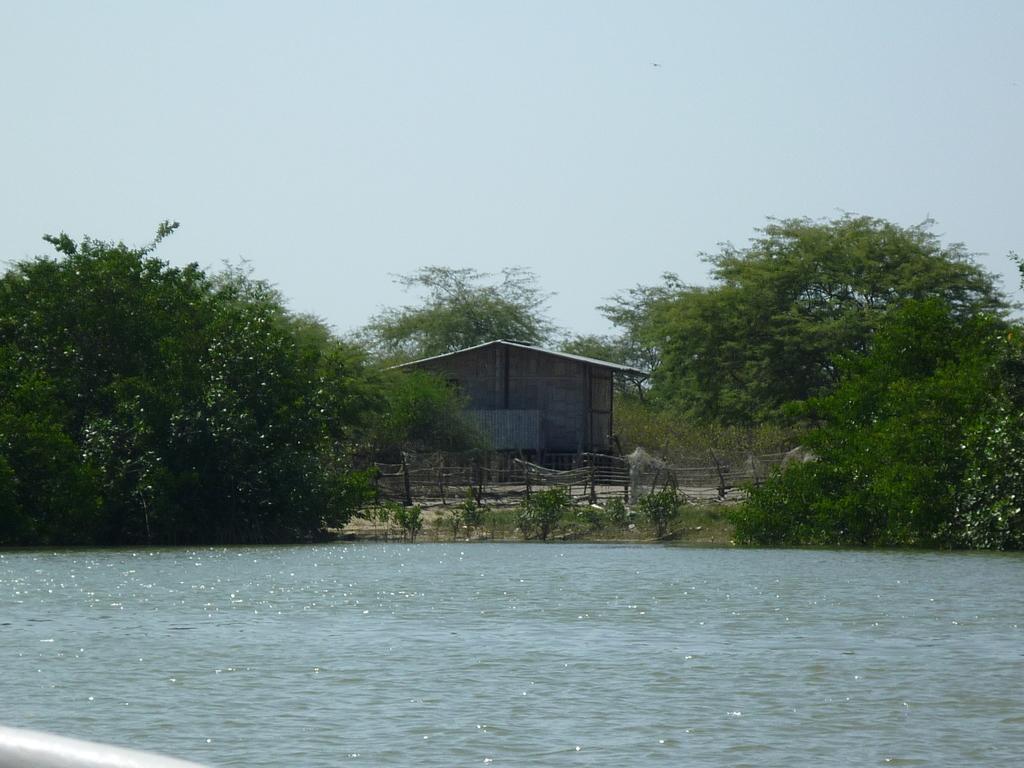Describe this image in one or two sentences. This image is taken outdoors. At the top of the image there is the sky. At the bottom of the image there is a pond with water. In the middle of the image there are many trees and plants with leaves, stems and branches. There is a house and there is a fence. 